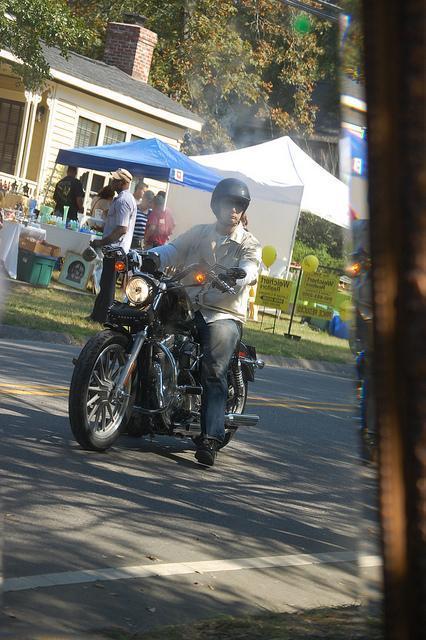How many people can be seen?
Give a very brief answer. 2. 